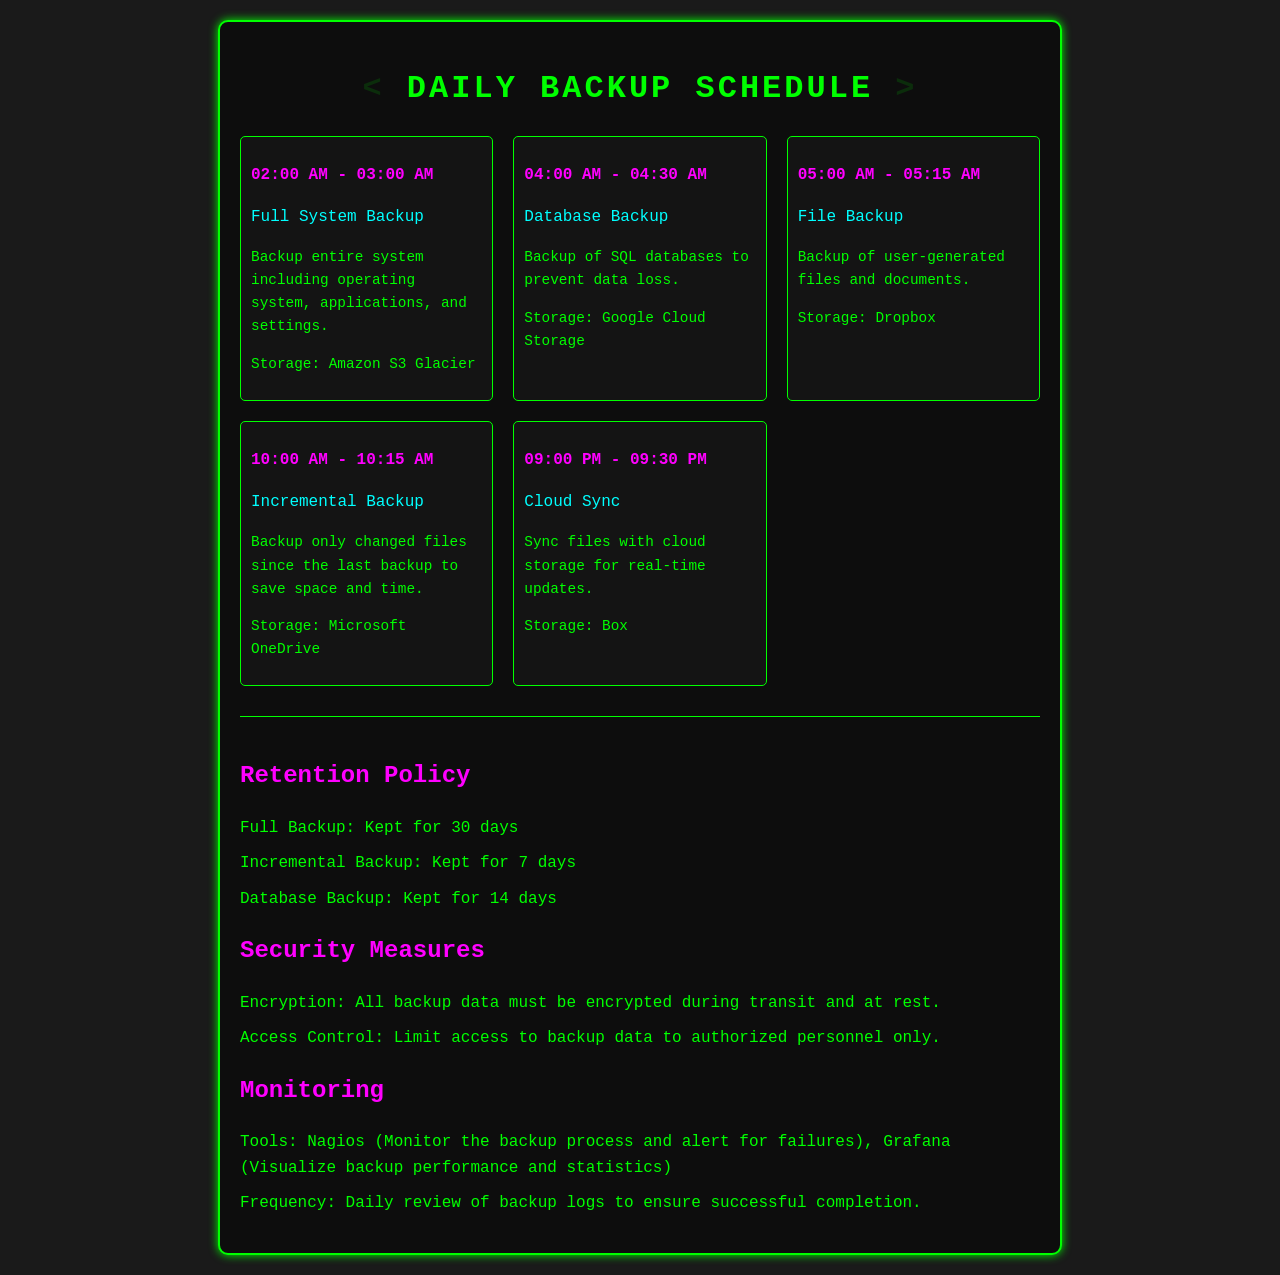What time is the Full System Backup scheduled? The Full System Backup is scheduled from 02:00 AM to 03:00 AM.
Answer: 02:00 AM - 03:00 AM What storage location is used for the Database Backup? The storage location for the Database Backup is Google Cloud Storage.
Answer: Google Cloud Storage What is the duration of the Incremental Backup? The Incremental Backup is scheduled for 15 minutes, from 10:00 AM to 10:15 AM.
Answer: 15 minutes How long is the Database Backup retained? The retention period for the Database Backup is specified in the retention policy section. It states that the Database Backup is kept for 14 days.
Answer: 14 days Which tool is mentioned for monitoring backup performance? The tool mentioned for visualizing backup performance is Grafana.
Answer: Grafana What type of backup occurs at 05:00 AM? At 05:00 AM, a File Backup occurs, as indicated in the schedule.
Answer: File Backup Where are user-generated files backed up? User-generated files are backed up to Dropbox, according to the storage detail for that task.
Answer: Dropbox What security measure is enforced for backup data? One of the security measures is encryption during transit and at rest, as noted in the document.
Answer: Encryption When is the Cloud Sync scheduled? The Cloud Sync is scheduled from 09:00 PM to 09:30 PM.
Answer: 09:00 PM - 09:30 PM 